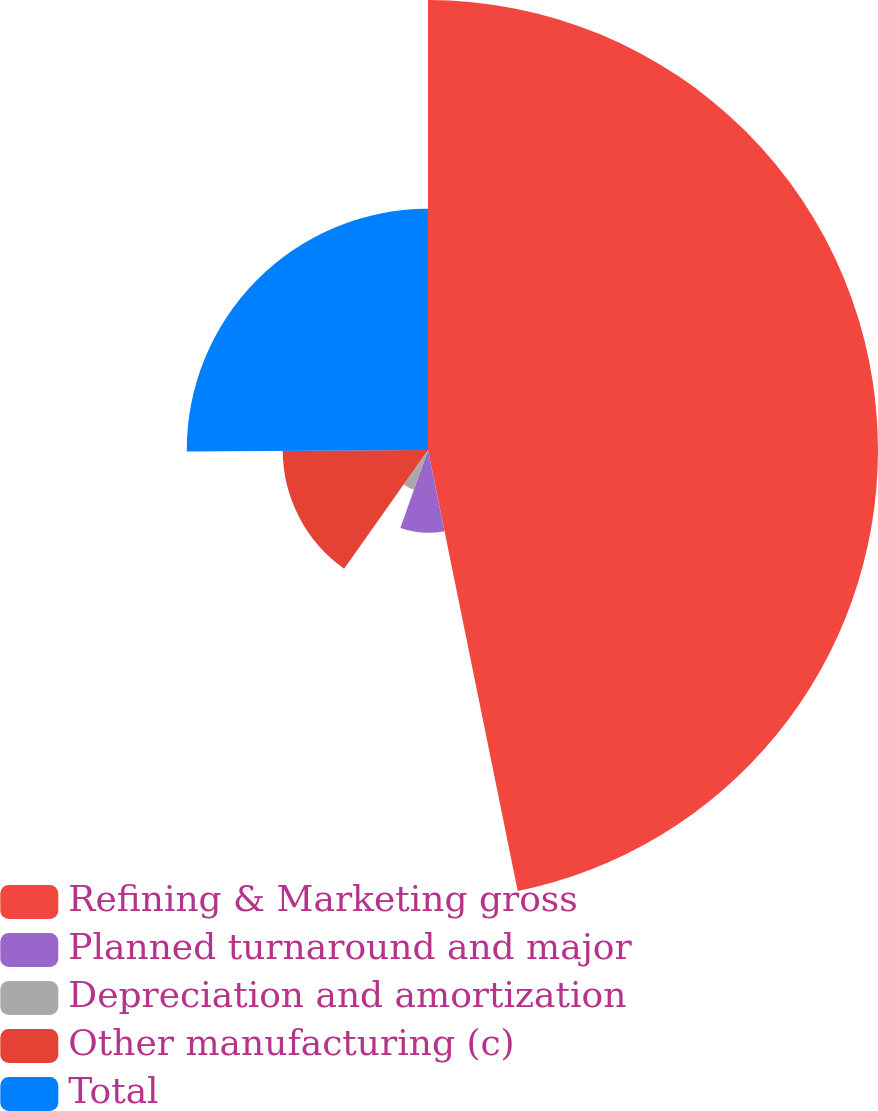Convert chart. <chart><loc_0><loc_0><loc_500><loc_500><pie_chart><fcel>Refining & Marketing gross<fcel>Planned turnaround and major<fcel>Depreciation and amortization<fcel>Other manufacturing (c)<fcel>Total<nl><fcel>46.8%<fcel>8.61%<fcel>4.38%<fcel>15.11%<fcel>25.09%<nl></chart> 